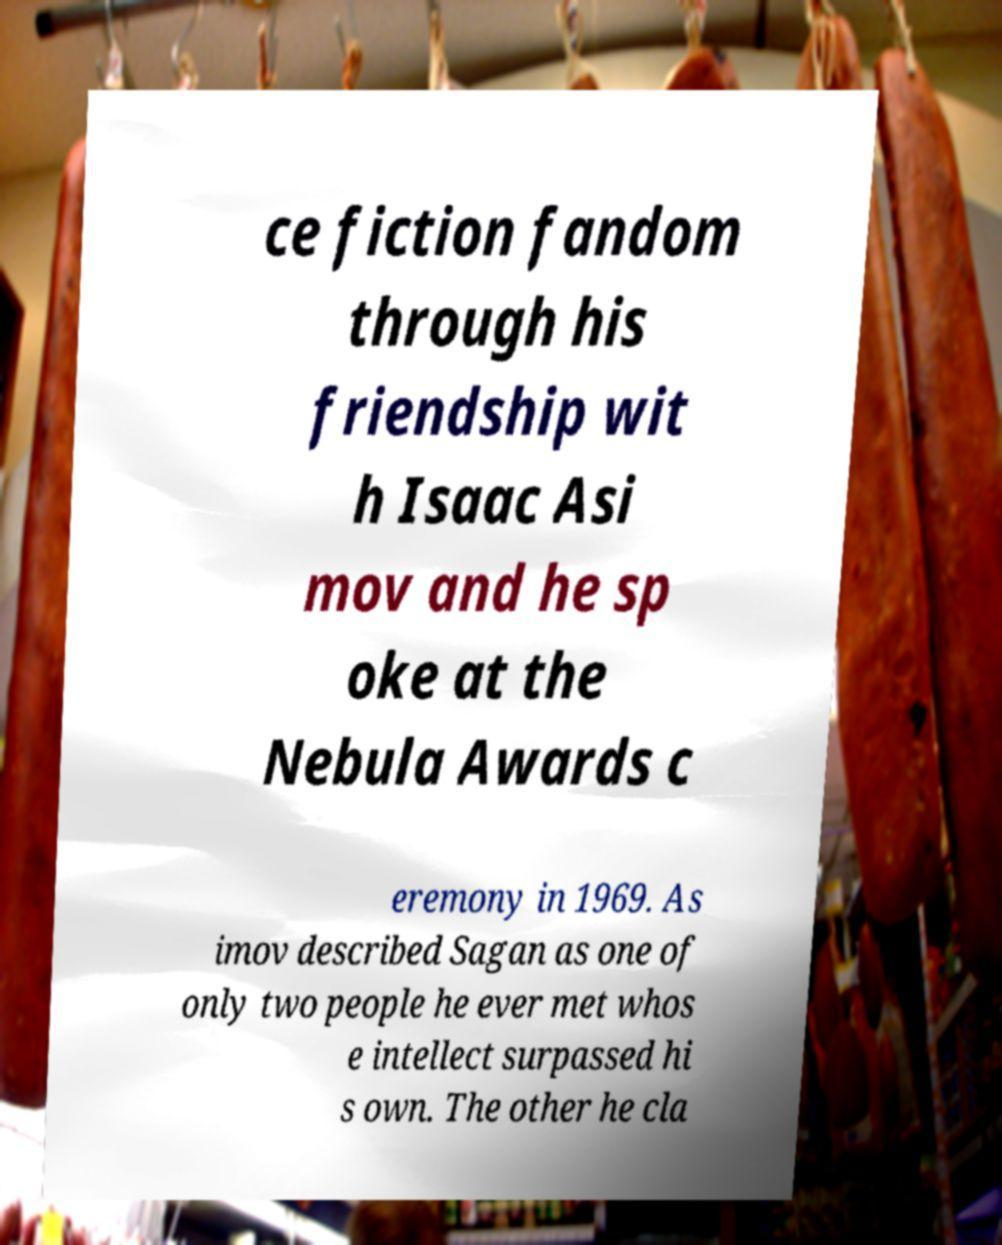Could you extract and type out the text from this image? ce fiction fandom through his friendship wit h Isaac Asi mov and he sp oke at the Nebula Awards c eremony in 1969. As imov described Sagan as one of only two people he ever met whos e intellect surpassed hi s own. The other he cla 